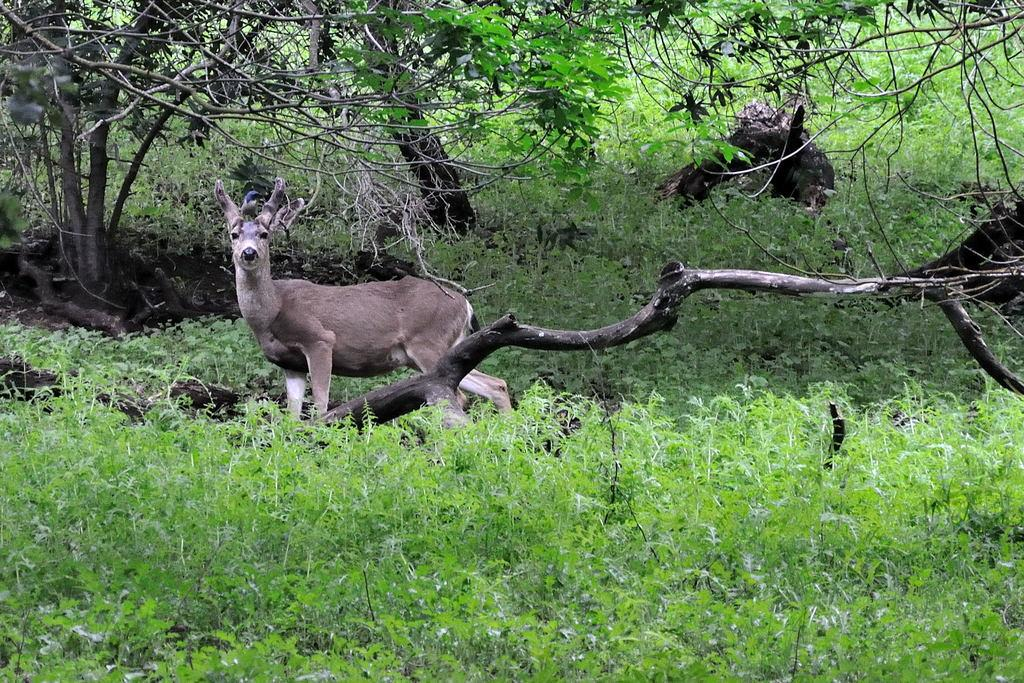What type of animal is in the image? There is a deer in the image. Is there anything unusual about the deer? Yes, there is a bird on the deer's head. What can be seen on the ground in the image? There are plants on the ground in the image. What type of vegetation is visible in the image? There are trees in the image. What type of glue is being used to hold the frame together in the image? There is no frame present in the image, so it is not possible to determine what type of glue might be used. 